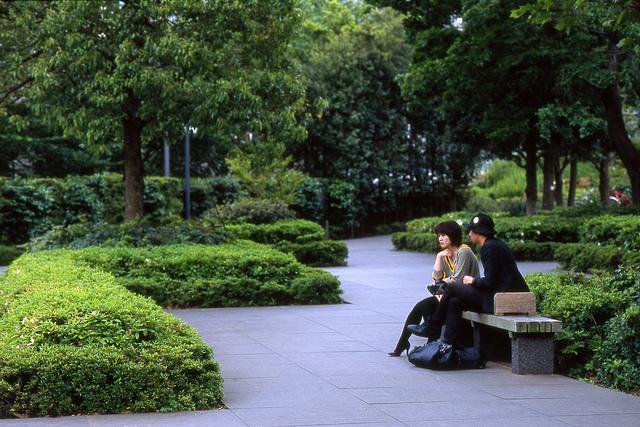How many people are in the picture?
Give a very brief answer. 2. How many people are there?
Give a very brief answer. 2. 